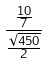Convert formula to latex. <formula><loc_0><loc_0><loc_500><loc_500>\frac { \frac { 1 0 } { 7 } } { \frac { \sqrt { 4 5 0 } } { 2 } }</formula> 